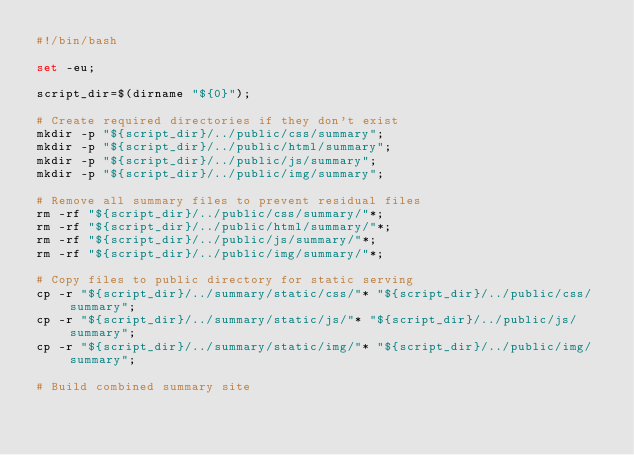<code> <loc_0><loc_0><loc_500><loc_500><_Bash_>#!/bin/bash

set -eu;

script_dir=$(dirname "${0}");

# Create required directories if they don't exist
mkdir -p "${script_dir}/../public/css/summary";
mkdir -p "${script_dir}/../public/html/summary";
mkdir -p "${script_dir}/../public/js/summary";
mkdir -p "${script_dir}/../public/img/summary";

# Remove all summary files to prevent residual files
rm -rf "${script_dir}/../public/css/summary/"*;
rm -rf "${script_dir}/../public/html/summary/"*;
rm -rf "${script_dir}/../public/js/summary/"*;
rm -rf "${script_dir}/../public/img/summary/"*;

# Copy files to public directory for static serving
cp -r "${script_dir}/../summary/static/css/"* "${script_dir}/../public/css/summary";
cp -r "${script_dir}/../summary/static/js/"* "${script_dir}/../public/js/summary";
cp -r "${script_dir}/../summary/static/img/"* "${script_dir}/../public/img/summary";

# Build combined summary site</code> 